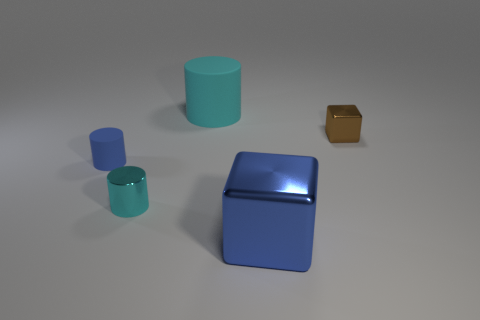Subtract all tiny blue cylinders. How many cylinders are left? 2 Subtract 1 cylinders. How many cylinders are left? 2 Subtract all cyan cylinders. How many cylinders are left? 1 Add 3 tiny cubes. How many objects exist? 8 Subtract all cubes. How many objects are left? 3 Subtract 0 red spheres. How many objects are left? 5 Subtract all blue cylinders. Subtract all purple blocks. How many cylinders are left? 2 Subtract all cyan balls. How many cyan cylinders are left? 2 Subtract all large red matte balls. Subtract all small brown things. How many objects are left? 4 Add 1 small brown cubes. How many small brown cubes are left? 2 